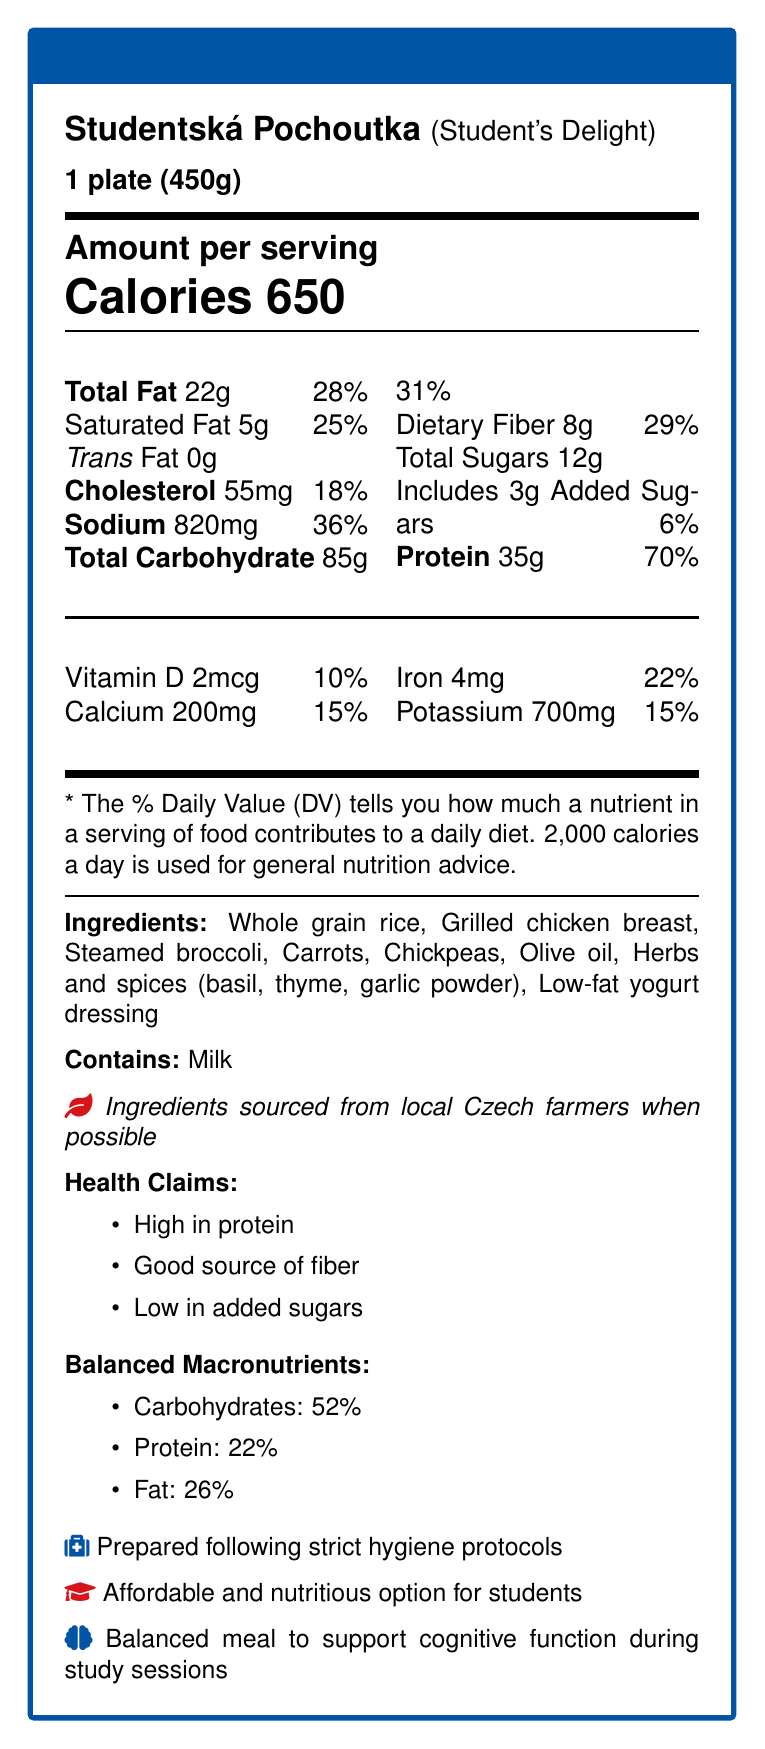what is the serving size of Studentská Pochoutka? The serving size is mentioned at the beginning of the document as "1 plate (450g)".
Answer: 1 plate (450g) how many calories are in one serving of Studentská Pochoutka? The document specifies that there are 650 calories per serving.
Answer: 650 what is the amount of dietary fiber per serving? The amount of dietary fiber is listed in the nutritional information as 8g.
Answer: 8g which ingredient is a source of protein in this meal? Grilled chicken breast is an ingredient known to be high in protein.
Answer: Grilled chicken breast does the meal contain any trans fats? The document states that the trans fat amount is 0g per serving.
Answer: No what percentage of the daily value is represented by the total fat content? The total fat content is 22g, which represents 28% of the daily value.
Answer: 28% which of the following is a health claim made about this meal? A. Low in sodium B. High in protein C. Contains added sugars D. High in cholesterol The document lists "High in protein" as one of the health claims.
Answer: B what mineral is present in the highest amount per serving? A. Calcium B. Iron C. Potassium D. Vitamin D Potassium is present in the highest amount per serving at 700mg.
Answer: C. Potassium is the meal prepared following strict hygiene protocols? The document mentions that the meal is prepared following strict hygiene protocols.
Answer: Yes summarize the main idea of the document. The document focuses on nutritional content, ingredients, health claims, and preparation practices of a university cafeteria meal.
Answer: The document provides the nutritional information for a meal called Studentská Pochoutka, highlighting its balanced macronutrient content, health benefits, ingredients, and adherence to hygiene protocols. what are the allergens present in the meal? The document lists Milk as the allergen present in the meal.
Answer: Milk how much calcium does one serving contain? One serving contains 200mg of calcium, as stated in the nutritional information.
Answer: 200mg what is the total carbohydrate content in the meal? The total carbohydrate content is 85g per serving according to the nutritional information.
Answer: 85g what percentage of the daily value is the protein content? The protein content is 35g, which represents 70% of the daily value.
Answer: 70% can you determine the exact recipe used to prepare Studentská Pochoutka from this document? The document lists the ingredients but does not provide the exact recipe or preparation method.
Answer: No what macronutrient is present in the highest proportion in this meal? The balanced macronutrients section indicates that carbohydrates make up 52% of the meal.
Answer: Carbohydrates which vitamins or minerals in the meal support immune function? Vitamin D and Iron are known to support immune function, and both are present in the meal.
Answer: Vitamin D, Iron 